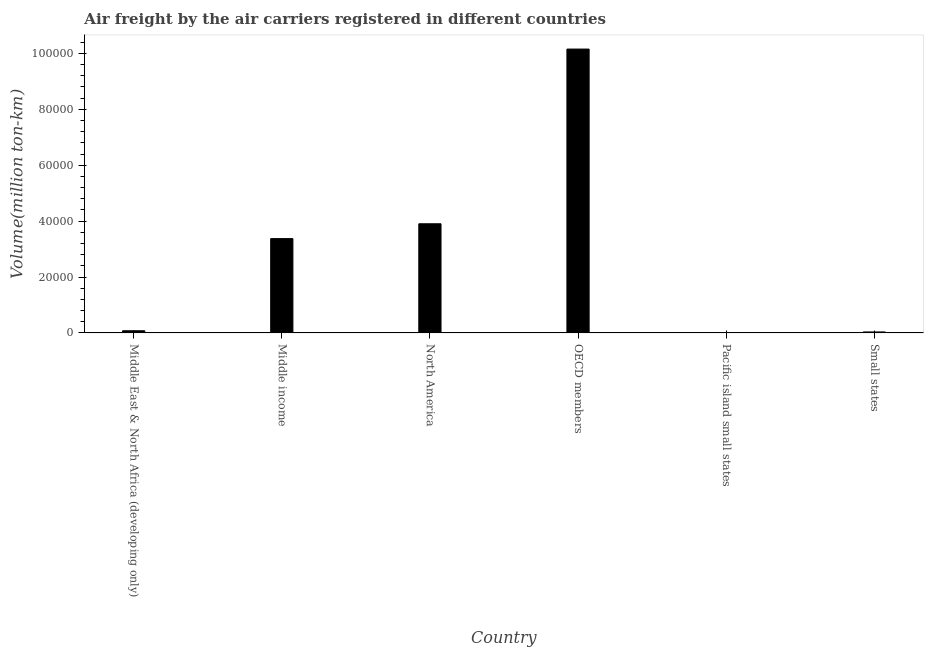What is the title of the graph?
Keep it short and to the point. Air freight by the air carriers registered in different countries. What is the label or title of the Y-axis?
Provide a succinct answer. Volume(million ton-km). What is the air freight in Small states?
Give a very brief answer. 356.2. Across all countries, what is the maximum air freight?
Your response must be concise. 1.02e+05. Across all countries, what is the minimum air freight?
Offer a very short reply. 75.74. In which country was the air freight maximum?
Offer a terse response. OECD members. In which country was the air freight minimum?
Give a very brief answer. Pacific island small states. What is the sum of the air freight?
Make the answer very short. 1.76e+05. What is the difference between the air freight in Middle East & North Africa (developing only) and OECD members?
Your answer should be compact. -1.01e+05. What is the average air freight per country?
Your answer should be compact. 2.93e+04. What is the median air freight?
Make the answer very short. 1.73e+04. What is the ratio of the air freight in Middle East & North Africa (developing only) to that in OECD members?
Provide a short and direct response. 0.01. Is the difference between the air freight in North America and OECD members greater than the difference between any two countries?
Ensure brevity in your answer.  No. What is the difference between the highest and the second highest air freight?
Keep it short and to the point. 6.25e+04. What is the difference between the highest and the lowest air freight?
Provide a succinct answer. 1.01e+05. How many countries are there in the graph?
Your response must be concise. 6. What is the Volume(million ton-km) of Middle East & North Africa (developing only)?
Make the answer very short. 780.22. What is the Volume(million ton-km) in Middle income?
Your answer should be very brief. 3.38e+04. What is the Volume(million ton-km) in North America?
Your response must be concise. 3.91e+04. What is the Volume(million ton-km) of OECD members?
Provide a succinct answer. 1.02e+05. What is the Volume(million ton-km) of Pacific island small states?
Make the answer very short. 75.74. What is the Volume(million ton-km) of Small states?
Offer a very short reply. 356.2. What is the difference between the Volume(million ton-km) in Middle East & North Africa (developing only) and Middle income?
Make the answer very short. -3.30e+04. What is the difference between the Volume(million ton-km) in Middle East & North Africa (developing only) and North America?
Provide a short and direct response. -3.83e+04. What is the difference between the Volume(million ton-km) in Middle East & North Africa (developing only) and OECD members?
Make the answer very short. -1.01e+05. What is the difference between the Volume(million ton-km) in Middle East & North Africa (developing only) and Pacific island small states?
Ensure brevity in your answer.  704.48. What is the difference between the Volume(million ton-km) in Middle East & North Africa (developing only) and Small states?
Make the answer very short. 424.02. What is the difference between the Volume(million ton-km) in Middle income and North America?
Ensure brevity in your answer.  -5306.64. What is the difference between the Volume(million ton-km) in Middle income and OECD members?
Provide a short and direct response. -6.78e+04. What is the difference between the Volume(million ton-km) in Middle income and Pacific island small states?
Your answer should be compact. 3.37e+04. What is the difference between the Volume(million ton-km) in Middle income and Small states?
Offer a very short reply. 3.34e+04. What is the difference between the Volume(million ton-km) in North America and OECD members?
Your answer should be compact. -6.25e+04. What is the difference between the Volume(million ton-km) in North America and Pacific island small states?
Your answer should be compact. 3.90e+04. What is the difference between the Volume(million ton-km) in North America and Small states?
Offer a very short reply. 3.87e+04. What is the difference between the Volume(million ton-km) in OECD members and Pacific island small states?
Make the answer very short. 1.01e+05. What is the difference between the Volume(million ton-km) in OECD members and Small states?
Your answer should be very brief. 1.01e+05. What is the difference between the Volume(million ton-km) in Pacific island small states and Small states?
Give a very brief answer. -280.46. What is the ratio of the Volume(million ton-km) in Middle East & North Africa (developing only) to that in Middle income?
Your response must be concise. 0.02. What is the ratio of the Volume(million ton-km) in Middle East & North Africa (developing only) to that in North America?
Keep it short and to the point. 0.02. What is the ratio of the Volume(million ton-km) in Middle East & North Africa (developing only) to that in OECD members?
Provide a succinct answer. 0.01. What is the ratio of the Volume(million ton-km) in Middle East & North Africa (developing only) to that in Pacific island small states?
Keep it short and to the point. 10.3. What is the ratio of the Volume(million ton-km) in Middle East & North Africa (developing only) to that in Small states?
Your answer should be compact. 2.19. What is the ratio of the Volume(million ton-km) in Middle income to that in North America?
Provide a succinct answer. 0.86. What is the ratio of the Volume(million ton-km) in Middle income to that in OECD members?
Your answer should be very brief. 0.33. What is the ratio of the Volume(million ton-km) in Middle income to that in Pacific island small states?
Make the answer very short. 445.63. What is the ratio of the Volume(million ton-km) in Middle income to that in Small states?
Provide a succinct answer. 94.76. What is the ratio of the Volume(million ton-km) in North America to that in OECD members?
Your answer should be compact. 0.39. What is the ratio of the Volume(million ton-km) in North America to that in Pacific island small states?
Your response must be concise. 515.7. What is the ratio of the Volume(million ton-km) in North America to that in Small states?
Offer a terse response. 109.66. What is the ratio of the Volume(million ton-km) in OECD members to that in Pacific island small states?
Provide a succinct answer. 1341.01. What is the ratio of the Volume(million ton-km) in OECD members to that in Small states?
Offer a terse response. 285.15. What is the ratio of the Volume(million ton-km) in Pacific island small states to that in Small states?
Your answer should be very brief. 0.21. 